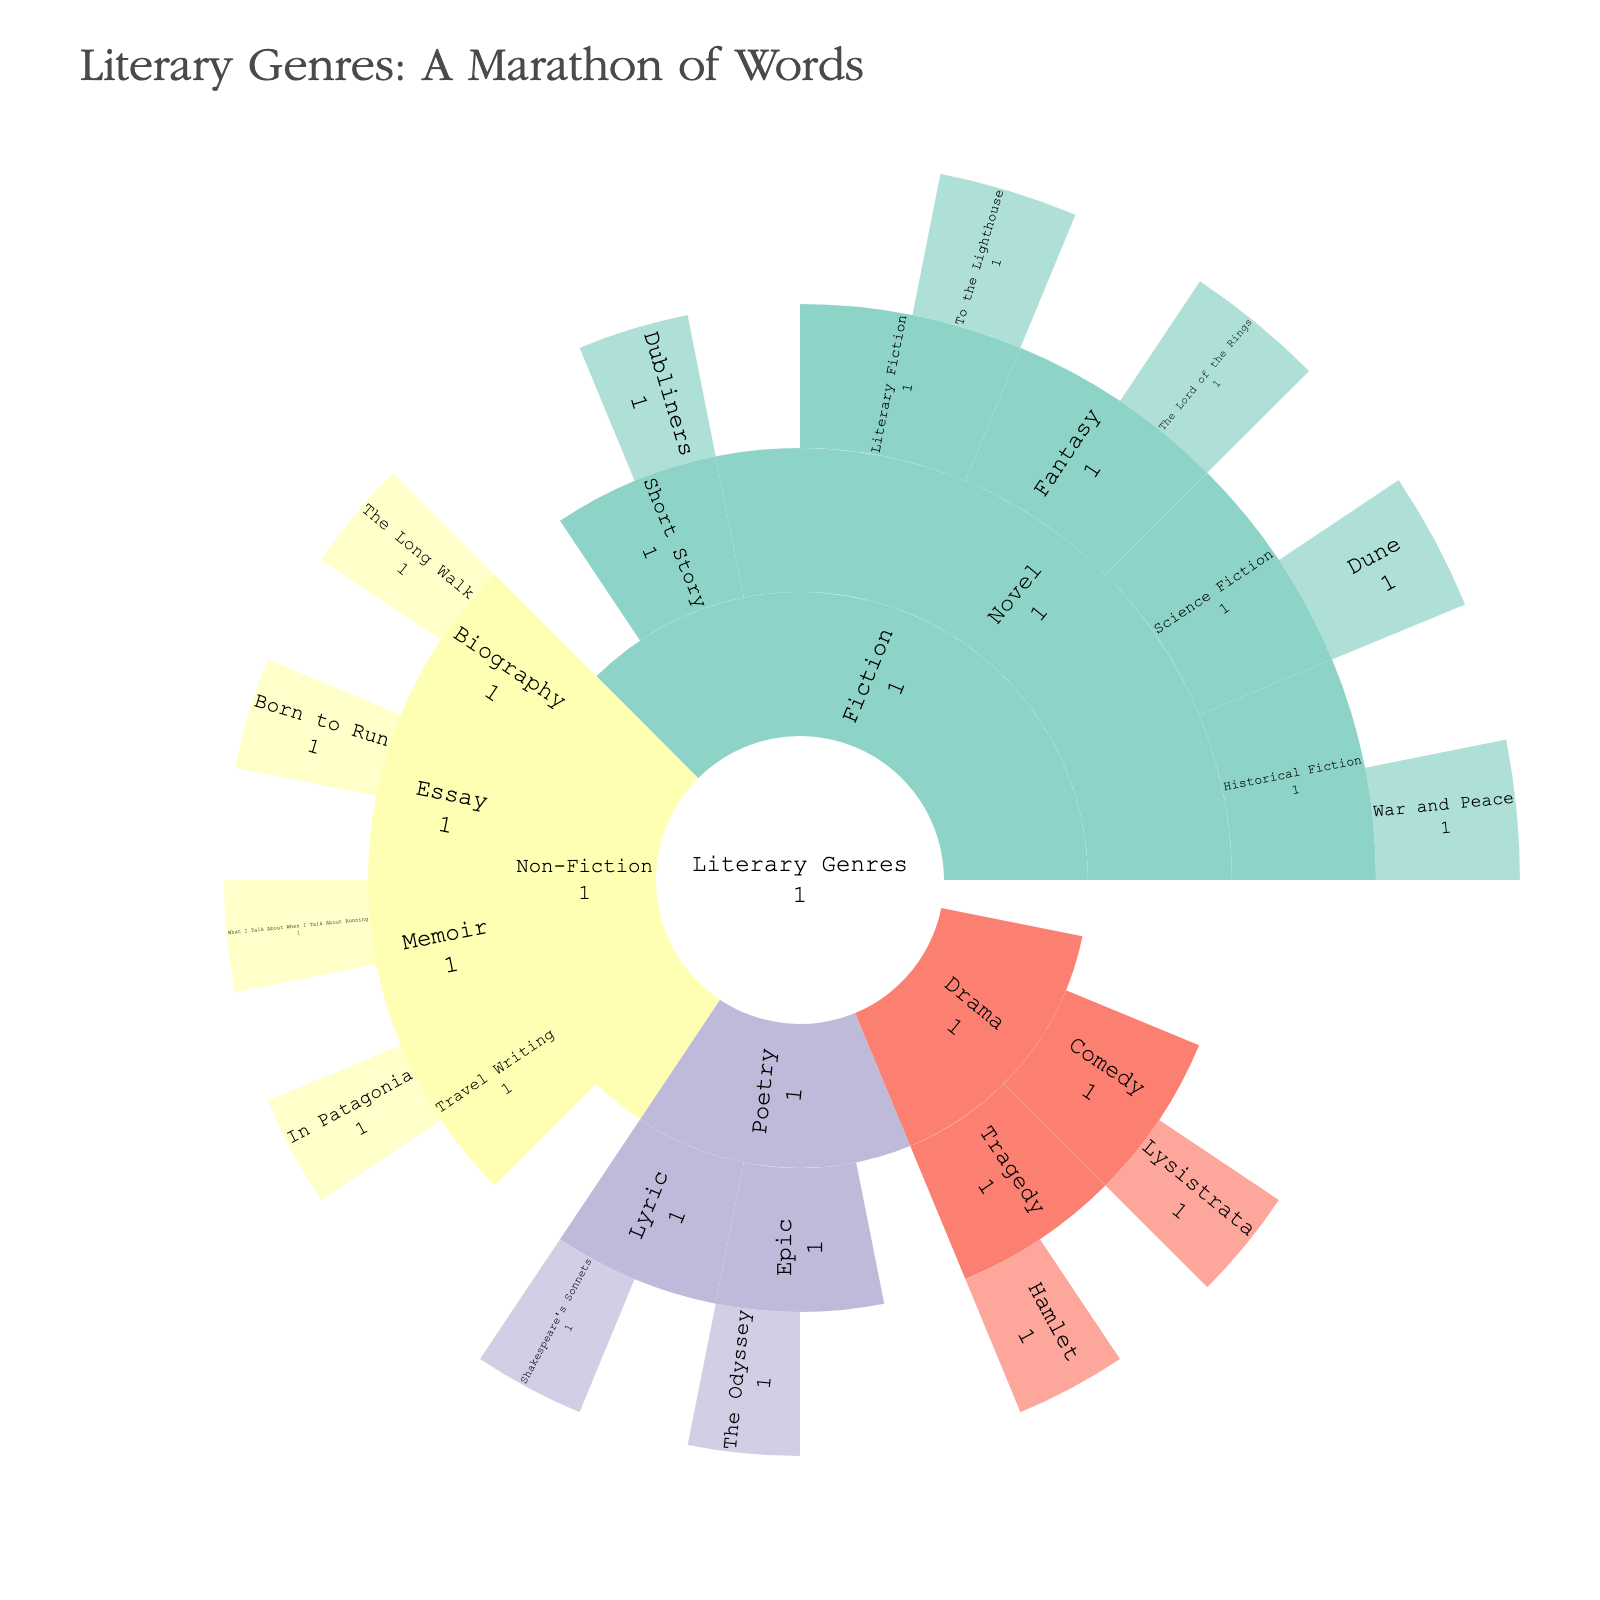Which literary genre has the highest number of subgenres? The sunburst plot shows that the "Fiction" genre has the most subgenres branching from it. When observing the plot, Fiction branches into Novel and Short Story, and further, the Novel branch splits into multiple subgenres such as Historical Fiction, Science Fiction, Fantasy, and Literary Fiction.
Answer: Fiction What is the title of the sunburst plot? The title of the sunburst plot is positioned at the top of the plot depicted in a larger font. According to the provided information, the title reads "Literary Genres: A Marathon of Words."
Answer: Literary Genres: A Marathon of Words Which subgenre contains the work "Dune"? By referring to the sunburst plot, we can trace the placement of "Dune". It is nested under the subgenre "Science Fiction," which falls under the genre "Fiction" and further under the category "Novel."
Answer: Science Fiction How many works are specifically highlighted under the genre "Poetry"? In the sunburst plot, we locate the "Poetry" genre and then its subgenres. "Lyric" has "Shakespeare's Sonnets," and "Epic" has "The Odyssey." There are no works associated with subgenres Lyric, and Epic, so the highlighted works under "Poetry" are two.
Answer: 2 Compare the number of highlighted works in "Drama" versus "Non-Fiction" genres In "Drama", there are highlighted works under "Tragedy" (Hamlet) and "Comedy" (Lysistrata), making a total of two works. In "Non-Fiction", there are highlighted works under "Biography" (The Long Walk), "Essay" (Born to Run), "Memoir" (What I Talk About When I Talk About Running), and "Travel Writing" (In Patagonia), making a total of four works.
Answer: Drama has fewer highlighted works Which genre contains the fewest subgenres? By examining the hierarchical levels in the plot, Poetry and Drama each show having two subgenres. The genres "Poetry" and "Drama" both have the fewest subgenres as compared to others.
Answer: Both Poetry and Drama Which work is related to marathon running? Observing the labels on the sunburst plot under the genres and subgenres, the work "What I Talk About When I Talk About Running" appears under the "Memoir" subgenre of "Non-Fiction." From the title, it’s clear that it relates to marathon running.
Answer: What I Talk About When I Talk About Running How many data points fall under the "Fiction" genre, including all subgenres and works? To determine this, count all the nodes within "Fiction." These include "Novel" and "Short Story," each with their subgenres as follows: Historical Fiction (1 Work: War and Peace), Science Fiction (1 Work: Dune), Fantasy (1 Work: The Lord of the Rings), Literary Fiction (1 Work: To the Lighthouse), and Short Story (1 Work: Dubliners). Total data points sum up to 8.
Answer: 8 